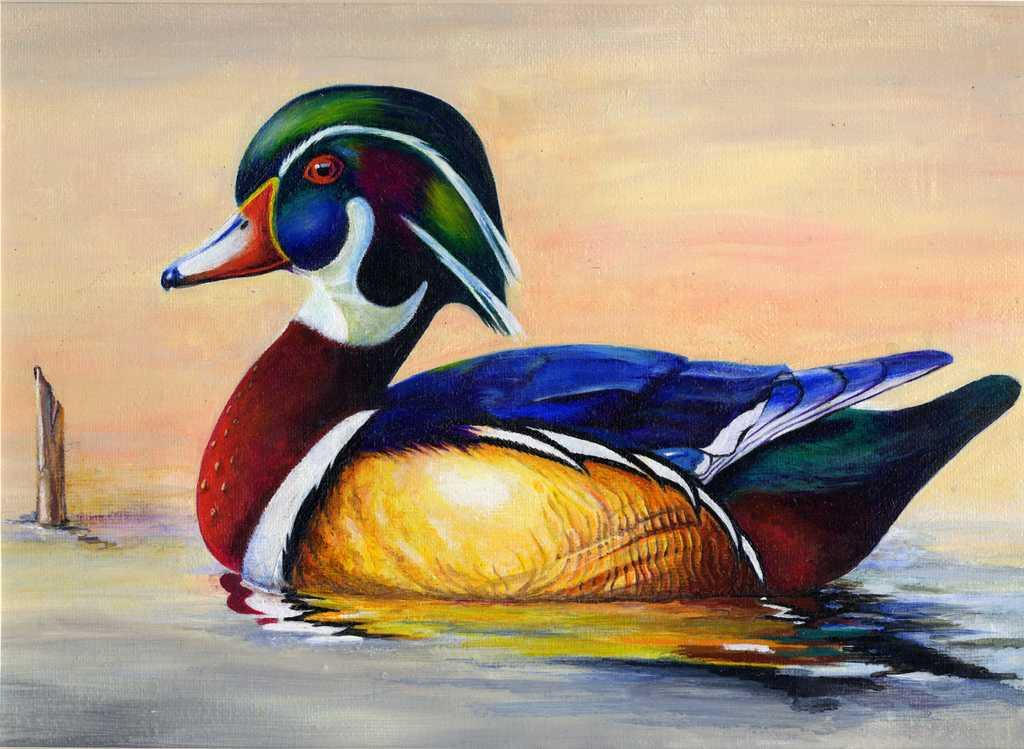What type of artwork is shown in the image? The image is a painting. What subject is depicted in the painting? The painting depicts a duck. Where is the duck located in the painting? The duck is in the water. What type of transport is the duck using in the painting? The painting does not show the duck using any form of transport; it is simply depicted as being in the water. Can you see a toothbrush or crown in the painting? No, there is no toothbrush or crown present in the painting. 